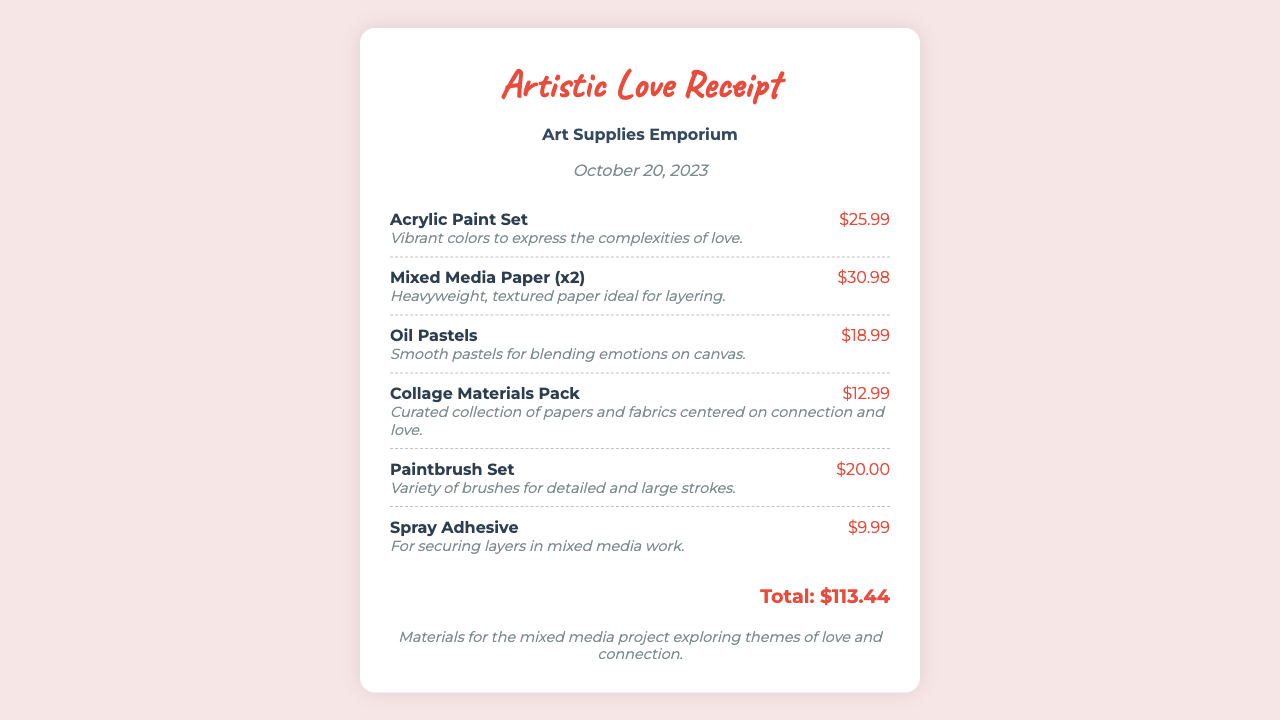what is the store name? The store name is listed prominently on the receipt, which in this case is "Art Supplies Emporium."
Answer: Art Supplies Emporium what is the date of the purchase? The date on the receipt indicates when the transaction took place. Here, it shows "October 20, 2023."
Answer: October 20, 2023 how many items were purchased? By counting the entries in the items section of the receipt, there are a total of six items listed.
Answer: 6 what is the total amount spent? The total amount is calculated as the sum of all item prices listed on the receipt, which is shown as "$113.44."
Answer: $113.44 what type of project are the materials for? The notes section describes the purpose of the purchased materials, which is to explore themes of love and connection.
Answer: mixed media project which item has the description related to blending emotions? Referring to item descriptions, the "Oil Pastels" is specifically noted for blending emotions on canvas.
Answer: Oil Pastels how many Mixed Media Papers were purchased? The receipt mentions "Mixed Media Paper (x2)," indicating two items of that type were purchased.
Answer: 2 what is the price of the Acrylic Paint Set? The receipt displays the price associated with the Acrylic Paint Set, which is stated as "$25.99."
Answer: $25.99 what color is the title of the receipt? The title of the receipt features a specific color that stands out, which is red identified as "#e74c3c."
Answer: red 